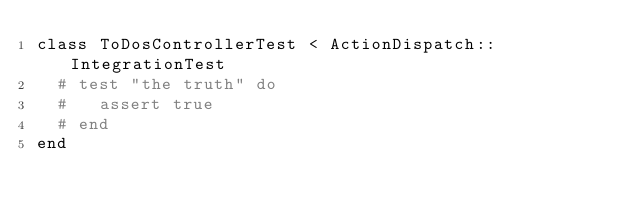Convert code to text. <code><loc_0><loc_0><loc_500><loc_500><_Ruby_>class ToDosControllerTest < ActionDispatch::IntegrationTest
  # test "the truth" do
  #   assert true
  # end
end
</code> 